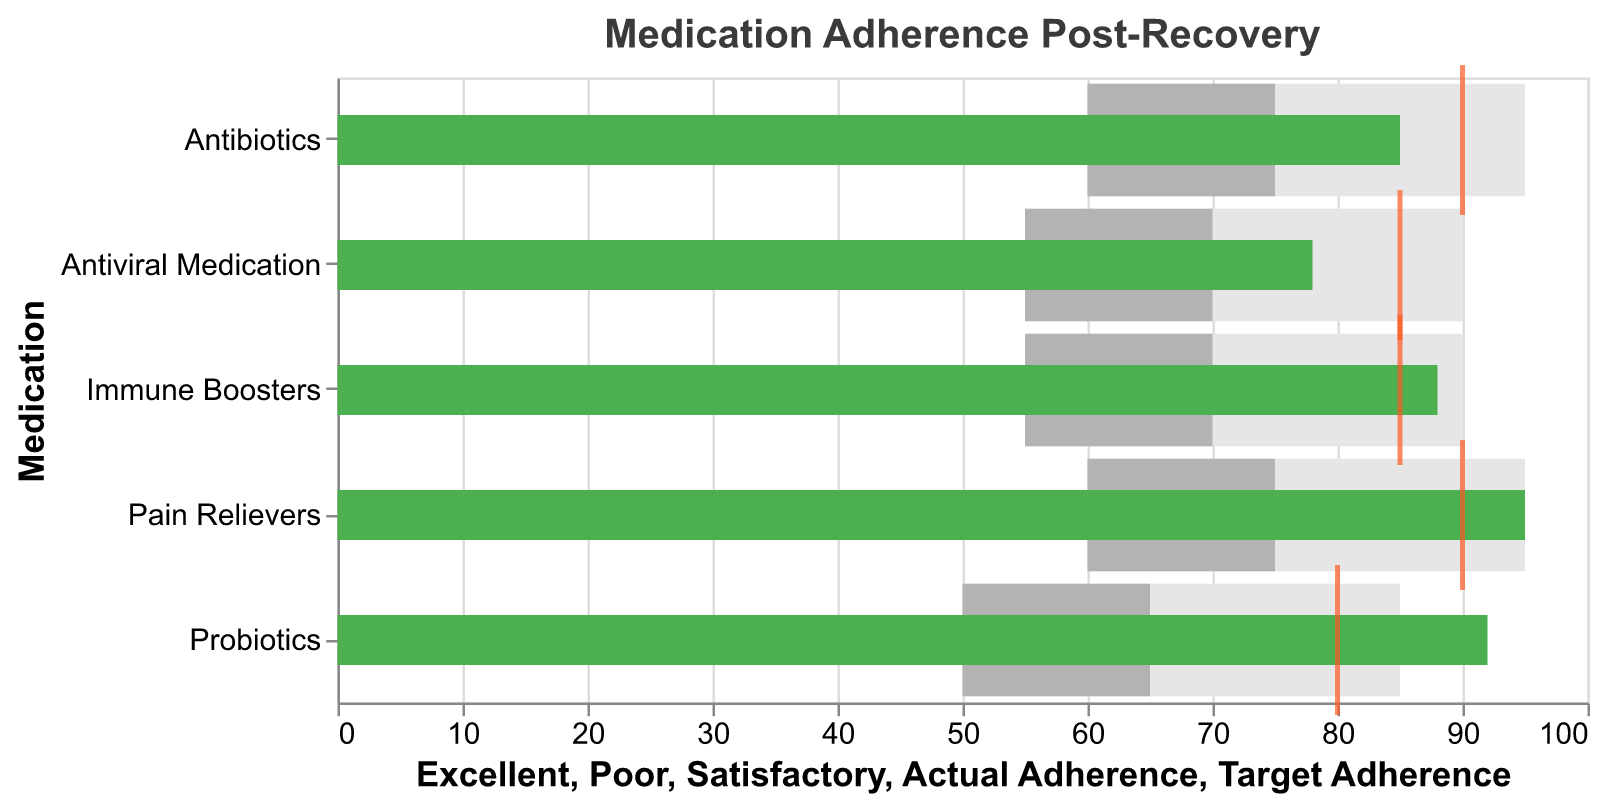What is the actual adherence rate for Pain Relievers? The actual adherence rate for Pain Relievers is depicted by the green bar at the Pain Relievers row.
Answer: 95 Which medication had the highest actual adherence rate? The green bars representing the actual adherence rates show that Pain Relievers have the highest actual adherence rate of 95.
Answer: Pain Relievers How does the actual adherence rate for Antiviral Medication compare to its target adherence? The actual adherence rate for Antiviral Medication is 78, shown by the green bar, while the target adherence is 85, indicated by the orange tick mark. The actual rate is below the target by 7 points.
Answer: Below by 7 points What is the difference between the actual adherence rate and target adherence rate for Immune Boosters? The green bar indicates the actual adherence rate of 88, and the orange tick indicates the target adherence rate of 85. The difference is 88 - 85 = 3.
Answer: 3 Which medication exceeds its target adherence rate? Comparing the green bars (actual adherence) with the orange ticks (target adherence) shows that Probiotics exceeds its target adherence rate as the green bar (92) is higher than the orange tick (80).
Answer: Probiotics How many medications met or exceeded their target adherence rates? By comparing the green bars with the orange ticks, Probiotics and Immune Boosters met or exceeded their target adherence rates.
Answer: 2 Is there any medication for which the actual adherence falls into the 'Poor' range? 'Poor' adherence is shown in light grey. None of the green bars (actual adherence) fall within the light grey range for any medication, indicating none of the actual adherence rates are in the 'Poor' range.
Answer: No For which medication is the gap between 'Satisfactory' and 'Excellent' adherence the largest? The grey bars indicate the ranges. Antiviral Medication has the widest 'Satisfactory' to 'Excellent' range stretching from 70 to 90, a gap of 20 points.
Answer: Antiviral Medication What is the target adherence rate for Antibiotics? The target adherence rate for Antibiotics is indicated by the orange tick mark, which is at 90.
Answer: 90 